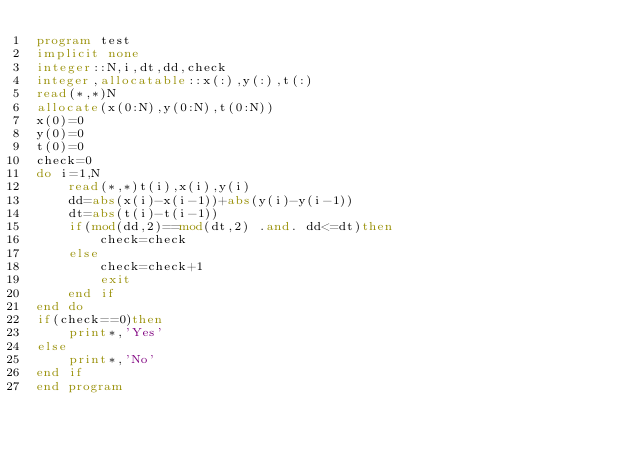Convert code to text. <code><loc_0><loc_0><loc_500><loc_500><_FORTRAN_>program test
implicit none
integer::N,i,dt,dd,check
integer,allocatable::x(:),y(:),t(:)
read(*,*)N
allocate(x(0:N),y(0:N),t(0:N))
x(0)=0
y(0)=0
t(0)=0
check=0
do i=1,N
	read(*,*)t(i),x(i),y(i)
	dd=abs(x(i)-x(i-1))+abs(y(i)-y(i-1))
    dt=abs(t(i)-t(i-1))
    if(mod(dd,2)==mod(dt,2) .and. dd<=dt)then
    	check=check
    else
    	check=check+1
        exit
    end if
end do
if(check==0)then
	print*,'Yes'
else 
	print*,'No'
end if
end program</code> 